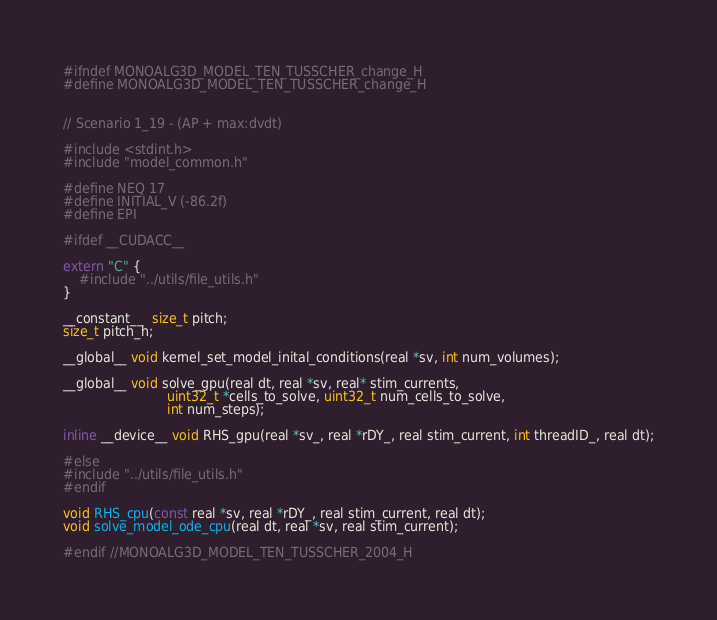Convert code to text. <code><loc_0><loc_0><loc_500><loc_500><_C_>
#ifndef MONOALG3D_MODEL_TEN_TUSSCHER_change_H
#define MONOALG3D_MODEL_TEN_TUSSCHER_change_H


// Scenario 1_19 - (AP + max:dvdt)

#include <stdint.h>
#include "model_common.h"

#define NEQ 17
#define INITIAL_V (-86.2f)
#define EPI

#ifdef __CUDACC__

extern "C" {
    #include "../utils/file_utils.h"
}

__constant__  size_t pitch;
size_t pitch_h;

__global__ void kernel_set_model_inital_conditions(real *sv, int num_volumes);

__global__ void solve_gpu(real dt, real *sv, real* stim_currents,
                          uint32_t *cells_to_solve, uint32_t num_cells_to_solve,
                          int num_steps);

inline __device__ void RHS_gpu(real *sv_, real *rDY_, real stim_current, int threadID_, real dt);

#else
#include "../utils/file_utils.h"
#endif

void RHS_cpu(const real *sv, real *rDY_, real stim_current, real dt);
void solve_model_ode_cpu(real dt, real *sv, real stim_current);

#endif //MONOALG3D_MODEL_TEN_TUSSCHER_2004_H
</code> 